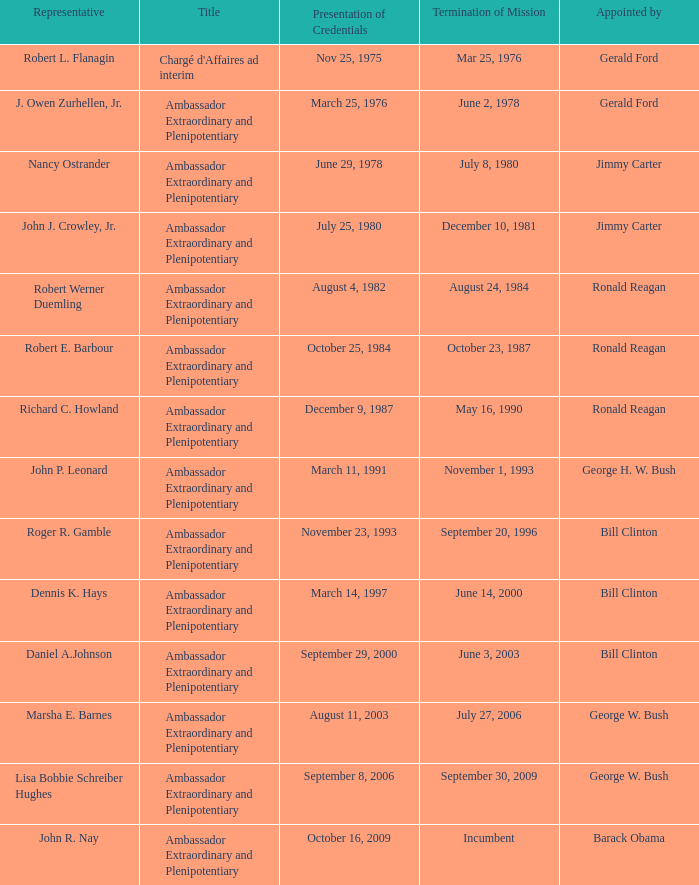Who appointed the representative that had a Presentation of Credentials on March 25, 1976? Gerald Ford. 